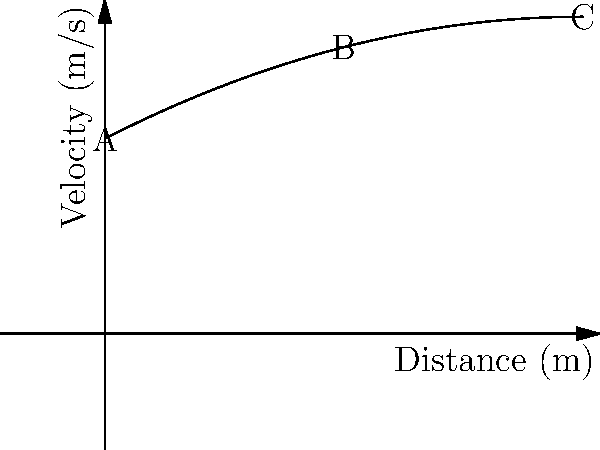The graph represents the relationship between a bullet's velocity and the distance it travels. The function is given by $v(d) = -0.002d^2 + 2d + 800$, where $v$ is the velocity in m/s and $d$ is the distance in meters. At what distance does the bullet reach its maximum velocity? To find the maximum velocity, we need to follow these steps:

1) The maximum point of a quadratic function occurs at the vertex of the parabola.

2) For a quadratic function in the form $f(x) = ax^2 + bx + c$, the x-coordinate of the vertex is given by $x = -\frac{b}{2a}$.

3) In our function $v(d) = -0.002d^2 + 2d + 800$, we have:
   $a = -0.002$
   $b = 2$
   $c = 800$

4) Applying the formula:
   $d = -\frac{b}{2a} = -\frac{2}{2(-0.002)} = -\frac{2}{-0.004} = 500$

5) Therefore, the maximum velocity occurs when the distance is 500 meters.

6) We can verify this by looking at the graph, where point C represents the highest point of the curve at 500 meters.
Answer: 500 meters 